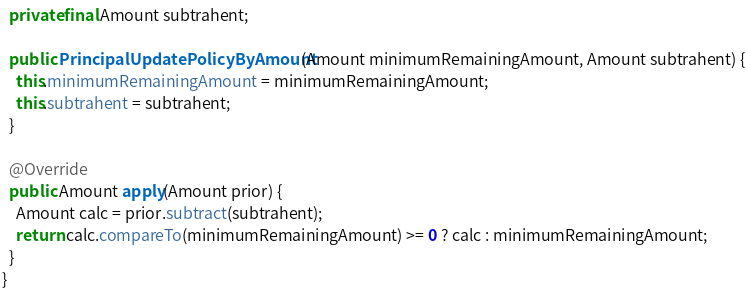<code> <loc_0><loc_0><loc_500><loc_500><_Java_>  private final Amount subtrahent;

  public PrincipalUpdatePolicyByAmount(Amount minimumRemainingAmount, Amount subtrahent) {
    this.minimumRemainingAmount = minimumRemainingAmount;
    this.subtrahent = subtrahent;
  }

  @Override
  public Amount apply(Amount prior) {
    Amount calc = prior.subtract(subtrahent);
    return calc.compareTo(minimumRemainingAmount) >= 0 ? calc : minimumRemainingAmount;
  }
}
</code> 